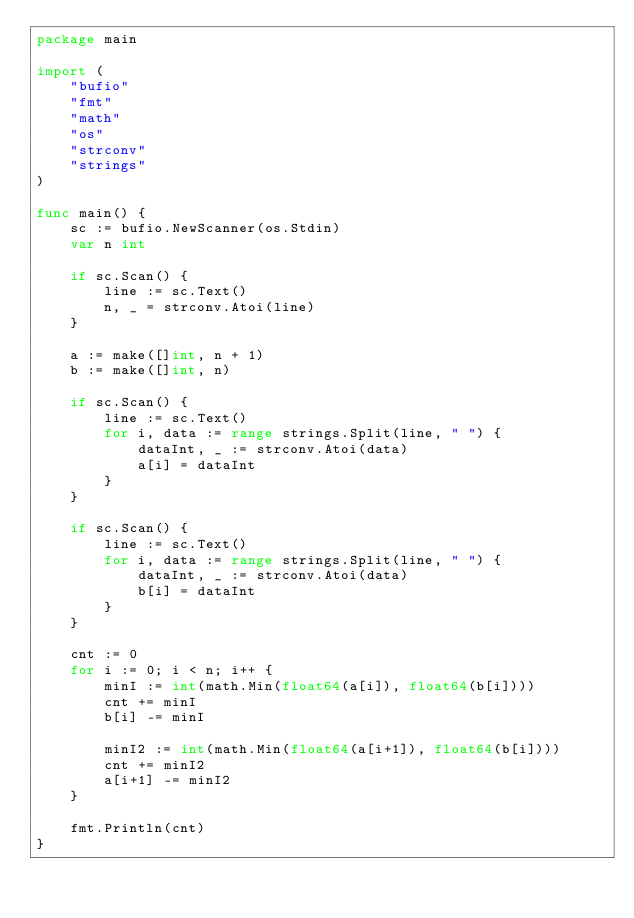<code> <loc_0><loc_0><loc_500><loc_500><_Go_>package main

import (
	"bufio"
	"fmt"
	"math"
	"os"
	"strconv"
	"strings"
)

func main() {
	sc := bufio.NewScanner(os.Stdin)
	var n int

	if sc.Scan() {
		line := sc.Text()
		n, _ = strconv.Atoi(line)
	}

	a := make([]int, n + 1)
	b := make([]int, n)

	if sc.Scan() {
		line := sc.Text()
		for i, data := range strings.Split(line, " ") {
			dataInt, _ := strconv.Atoi(data)
			a[i] = dataInt
		}
	}

	if sc.Scan() {
		line := sc.Text()
		for i, data := range strings.Split(line, " ") {
			dataInt, _ := strconv.Atoi(data)
			b[i] = dataInt
		}
	}

	cnt := 0
	for i := 0; i < n; i++ {
		minI := int(math.Min(float64(a[i]), float64(b[i])))
		cnt += minI
		b[i] -= minI

		minI2 := int(math.Min(float64(a[i+1]), float64(b[i])))
		cnt += minI2
		a[i+1] -= minI2
	}

	fmt.Println(cnt)
}
</code> 